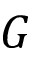Convert formula to latex. <formula><loc_0><loc_0><loc_500><loc_500>G</formula> 